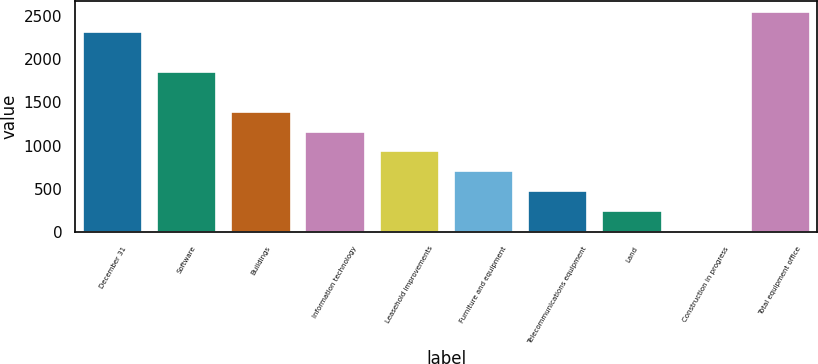Convert chart to OTSL. <chart><loc_0><loc_0><loc_500><loc_500><bar_chart><fcel>December 31<fcel>Software<fcel>Buildings<fcel>Information technology<fcel>Leasehold improvements<fcel>Furniture and equipment<fcel>Telecommunications equipment<fcel>Land<fcel>Construction in progress<fcel>Total equipment office<nl><fcel>2308<fcel>1849.4<fcel>1390.8<fcel>1161.5<fcel>932.2<fcel>702.9<fcel>473.6<fcel>244.3<fcel>15<fcel>2537.3<nl></chart> 